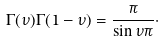<formula> <loc_0><loc_0><loc_500><loc_500>\Gamma ( \nu ) \Gamma ( 1 - \nu ) = \frac { \pi } { \sin \nu \pi } \cdot</formula> 